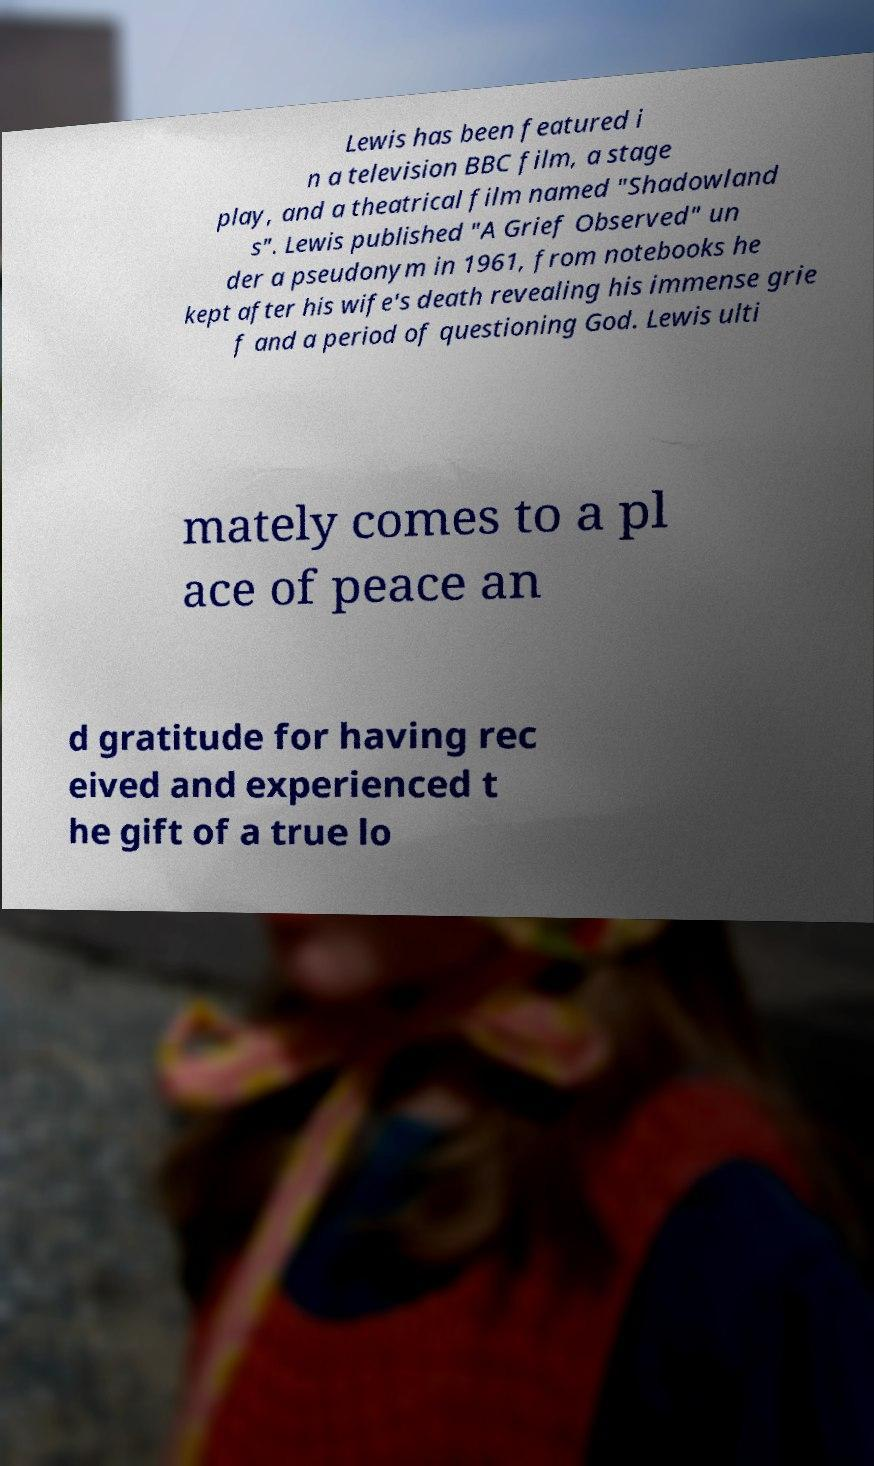There's text embedded in this image that I need extracted. Can you transcribe it verbatim? Lewis has been featured i n a television BBC film, a stage play, and a theatrical film named "Shadowland s". Lewis published "A Grief Observed" un der a pseudonym in 1961, from notebooks he kept after his wife's death revealing his immense grie f and a period of questioning God. Lewis ulti mately comes to a pl ace of peace an d gratitude for having rec eived and experienced t he gift of a true lo 